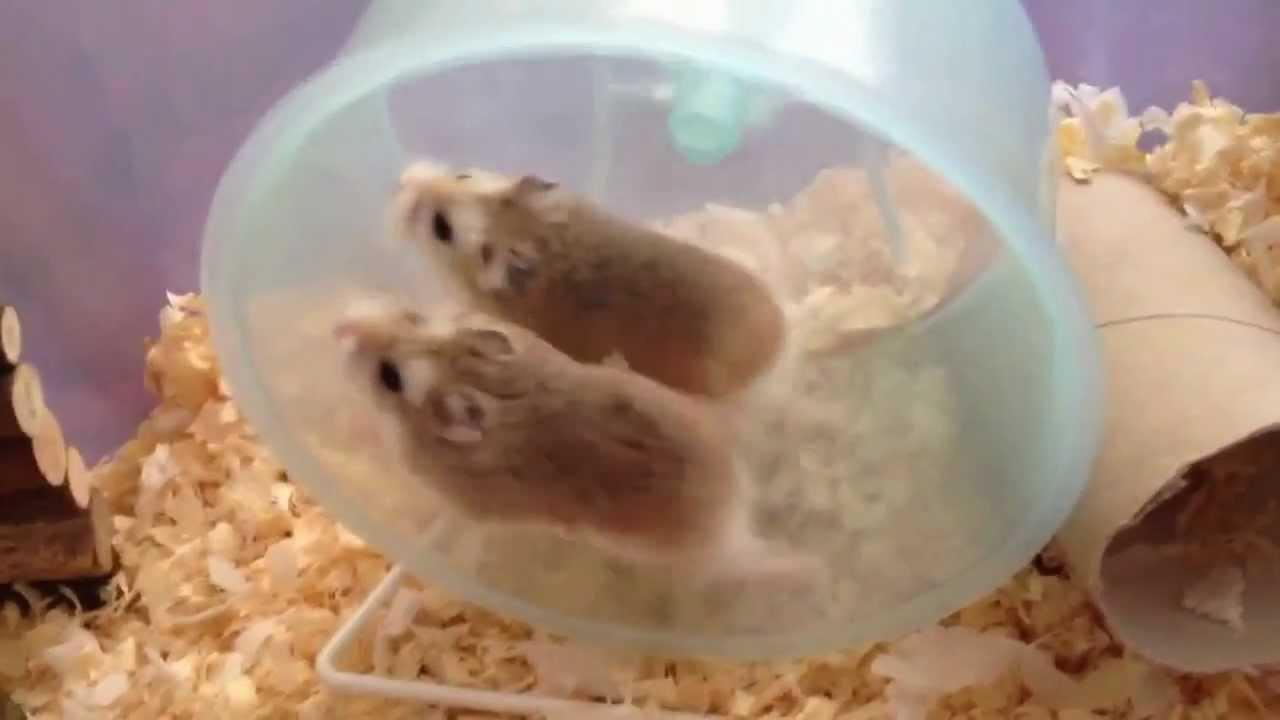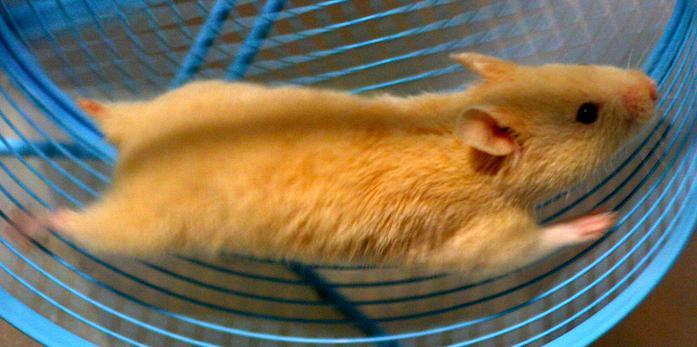The first image is the image on the left, the second image is the image on the right. Given the left and right images, does the statement "the right image has a hamster in a wheel made of blue metal" hold true? Answer yes or no. Yes. The first image is the image on the left, the second image is the image on the right. Assess this claim about the two images: "One image has two mice running in a hamster wheel.". Correct or not? Answer yes or no. Yes. 